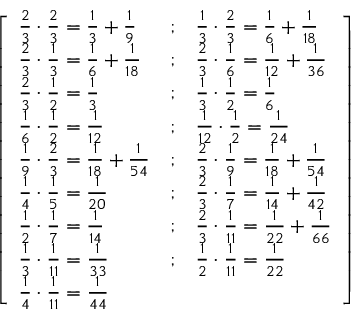Convert formula to latex. <formula><loc_0><loc_0><loc_500><loc_500>{ \left [ \begin{array} { l l l } { { \frac { 2 } { 3 } } \cdot { \frac { 2 } { 3 } } = { \frac { 1 } { 3 } } + { \frac { 1 } { 9 } } } & { ; } & { { \frac { 1 } { 3 } } \cdot { \frac { 2 } { 3 } } = { \frac { 1 } { 6 } } + { \frac { 1 } { 1 8 } } } \\ { { \frac { 2 } { 3 } } \cdot { \frac { 1 } { 3 } } = { \frac { 1 } { 6 } } + { \frac { 1 } { 1 8 } } } & { ; } & { { \frac { 2 } { 3 } } \cdot { \frac { 1 } { 6 } } = { \frac { 1 } { 1 2 } } + { \frac { 1 } { 3 6 } } } \\ { { \frac { 2 } { 3 } } \cdot { \frac { 1 } { 2 } } = { \frac { 1 } { 3 } } } & { ; } & { { \frac { 1 } { 3 } } \cdot { \frac { 1 } { 2 } } = { \frac { 1 } { 6 } } } \\ { { \frac { 1 } { 6 } } \cdot { \frac { 1 } { 2 } } = { \frac { 1 } { 1 2 } } } & { ; } & { { \frac { 1 } { 1 2 } } \cdot { \frac { 1 } { 2 } } = { \frac { 1 } { 2 4 } } } \\ { { \frac { 1 } { 9 } } \cdot { \frac { 2 } { 3 } } = { \frac { 1 } { 1 8 } } + { \frac { 1 } { 5 4 } } } & { ; } & { { \frac { 2 } { 3 } } \cdot { \frac { 1 } { 9 } } = { \frac { 1 } { 1 8 } } + { \frac { 1 } { 5 4 } } } \\ { { \frac { 1 } { 4 } } \cdot { \frac { 1 } { 5 } } = { \frac { 1 } { 2 0 } } } & { ; } & { { \frac { 2 } { 3 } } \cdot { \frac { 1 } { 7 } } = { \frac { 1 } { 1 4 } } + { \frac { 1 } { 4 2 } } } \\ { { \frac { 1 } { 2 } } \cdot { \frac { 1 } { 7 } } = { \frac { 1 } { 1 4 } } } & { ; } & { { \frac { 2 } { 3 } } \cdot { \frac { 1 } { 1 1 } } = { \frac { 1 } { 2 2 } } + { \frac { 1 } { 6 6 } } } \\ { { \frac { 1 } { 3 } } \cdot { \frac { 1 } { 1 1 } } = { \frac { 1 } { 3 3 } } } & { ; } & { { \frac { 1 } { 2 } } \cdot { \frac { 1 } { 1 1 } } = { \frac { 1 } { 2 2 } } } \\ { { \frac { 1 } { 4 } } \cdot { \frac { 1 } { 1 1 } } = { \frac { 1 } { 4 4 } } } & & \end{array} \right ] }</formula> 